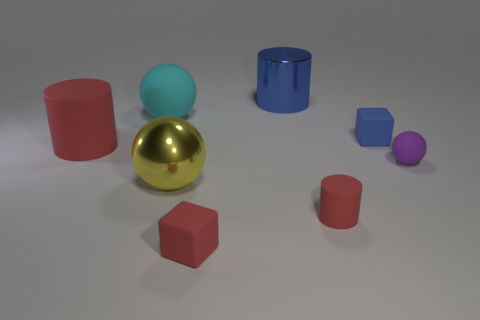Add 1 blue cylinders. How many objects exist? 9 Subtract all blocks. How many objects are left? 6 Subtract all big cyan balls. Subtract all tiny blocks. How many objects are left? 5 Add 6 cubes. How many cubes are left? 8 Add 4 small red things. How many small red things exist? 6 Subtract 0 green balls. How many objects are left? 8 